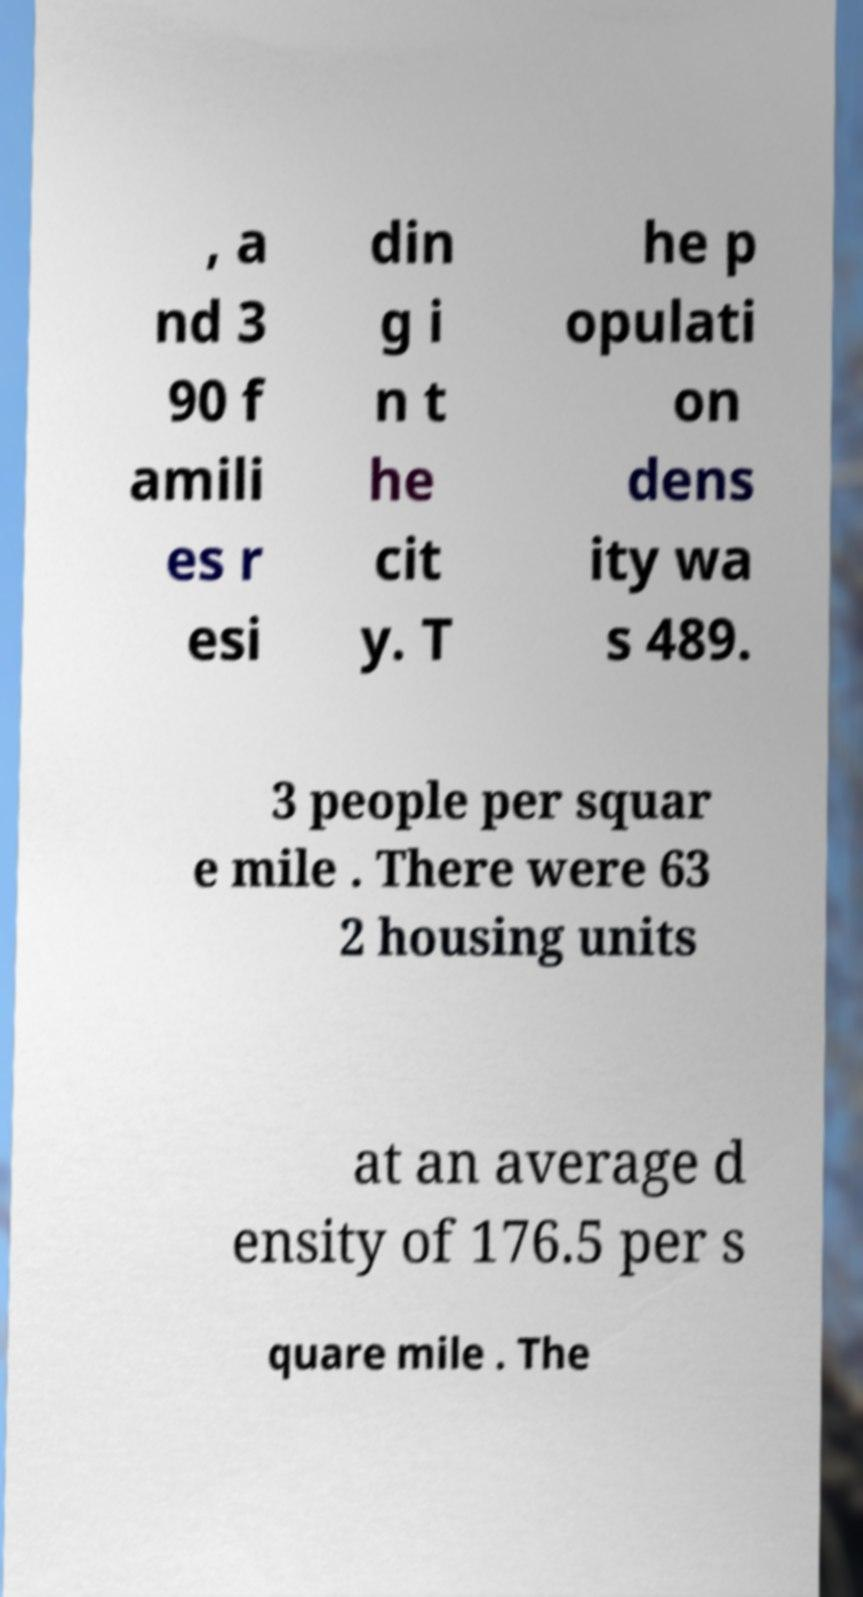Please read and relay the text visible in this image. What does it say? , a nd 3 90 f amili es r esi din g i n t he cit y. T he p opulati on dens ity wa s 489. 3 people per squar e mile . There were 63 2 housing units at an average d ensity of 176.5 per s quare mile . The 